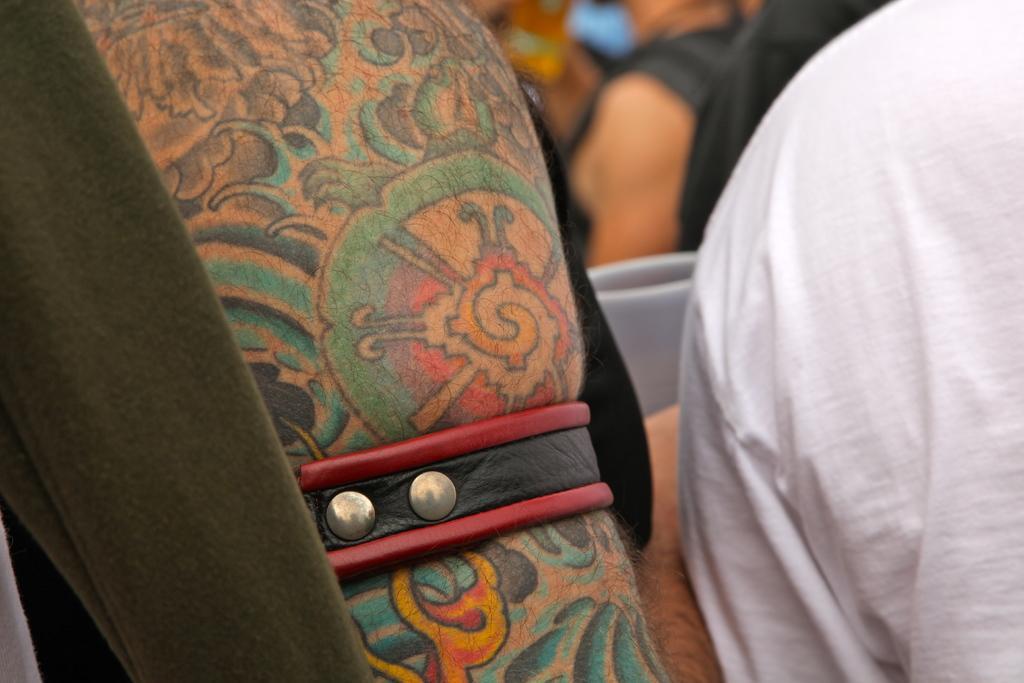Please provide a concise description of this image. In this picture we can see group of people and blurry background. 